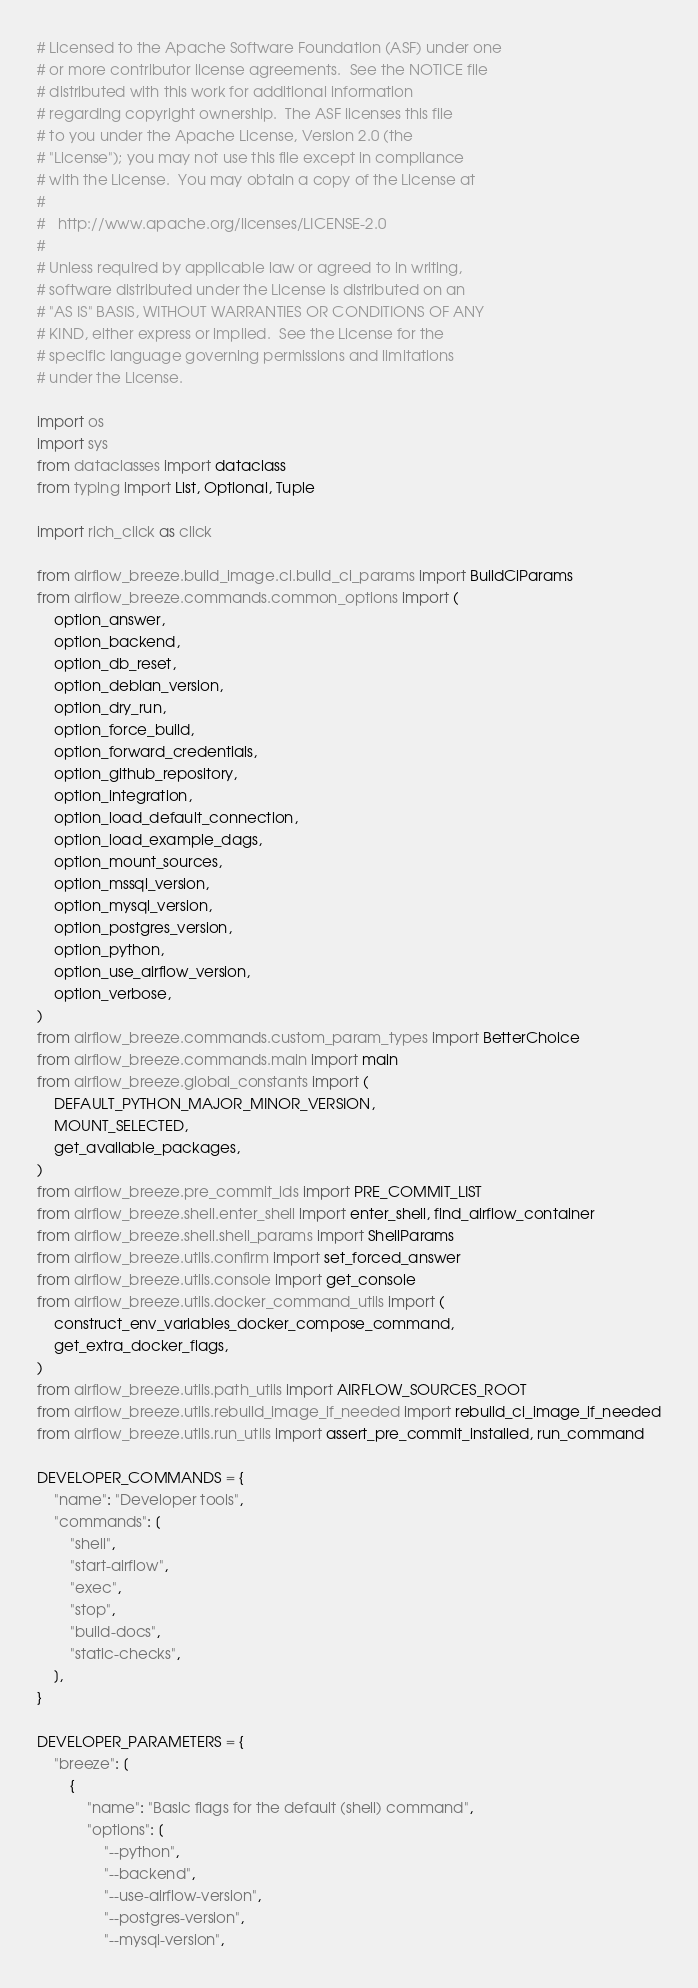Convert code to text. <code><loc_0><loc_0><loc_500><loc_500><_Python_># Licensed to the Apache Software Foundation (ASF) under one
# or more contributor license agreements.  See the NOTICE file
# distributed with this work for additional information
# regarding copyright ownership.  The ASF licenses this file
# to you under the Apache License, Version 2.0 (the
# "License"); you may not use this file except in compliance
# with the License.  You may obtain a copy of the License at
#
#   http://www.apache.org/licenses/LICENSE-2.0
#
# Unless required by applicable law or agreed to in writing,
# software distributed under the License is distributed on an
# "AS IS" BASIS, WITHOUT WARRANTIES OR CONDITIONS OF ANY
# KIND, either express or implied.  See the License for the
# specific language governing permissions and limitations
# under the License.

import os
import sys
from dataclasses import dataclass
from typing import List, Optional, Tuple

import rich_click as click

from airflow_breeze.build_image.ci.build_ci_params import BuildCiParams
from airflow_breeze.commands.common_options import (
    option_answer,
    option_backend,
    option_db_reset,
    option_debian_version,
    option_dry_run,
    option_force_build,
    option_forward_credentials,
    option_github_repository,
    option_integration,
    option_load_default_connection,
    option_load_example_dags,
    option_mount_sources,
    option_mssql_version,
    option_mysql_version,
    option_postgres_version,
    option_python,
    option_use_airflow_version,
    option_verbose,
)
from airflow_breeze.commands.custom_param_types import BetterChoice
from airflow_breeze.commands.main import main
from airflow_breeze.global_constants import (
    DEFAULT_PYTHON_MAJOR_MINOR_VERSION,
    MOUNT_SELECTED,
    get_available_packages,
)
from airflow_breeze.pre_commit_ids import PRE_COMMIT_LIST
from airflow_breeze.shell.enter_shell import enter_shell, find_airflow_container
from airflow_breeze.shell.shell_params import ShellParams
from airflow_breeze.utils.confirm import set_forced_answer
from airflow_breeze.utils.console import get_console
from airflow_breeze.utils.docker_command_utils import (
    construct_env_variables_docker_compose_command,
    get_extra_docker_flags,
)
from airflow_breeze.utils.path_utils import AIRFLOW_SOURCES_ROOT
from airflow_breeze.utils.rebuild_image_if_needed import rebuild_ci_image_if_needed
from airflow_breeze.utils.run_utils import assert_pre_commit_installed, run_command

DEVELOPER_COMMANDS = {
    "name": "Developer tools",
    "commands": [
        "shell",
        "start-airflow",
        "exec",
        "stop",
        "build-docs",
        "static-checks",
    ],
}

DEVELOPER_PARAMETERS = {
    "breeze": [
        {
            "name": "Basic flags for the default (shell) command",
            "options": [
                "--python",
                "--backend",
                "--use-airflow-version",
                "--postgres-version",
                "--mysql-version",</code> 